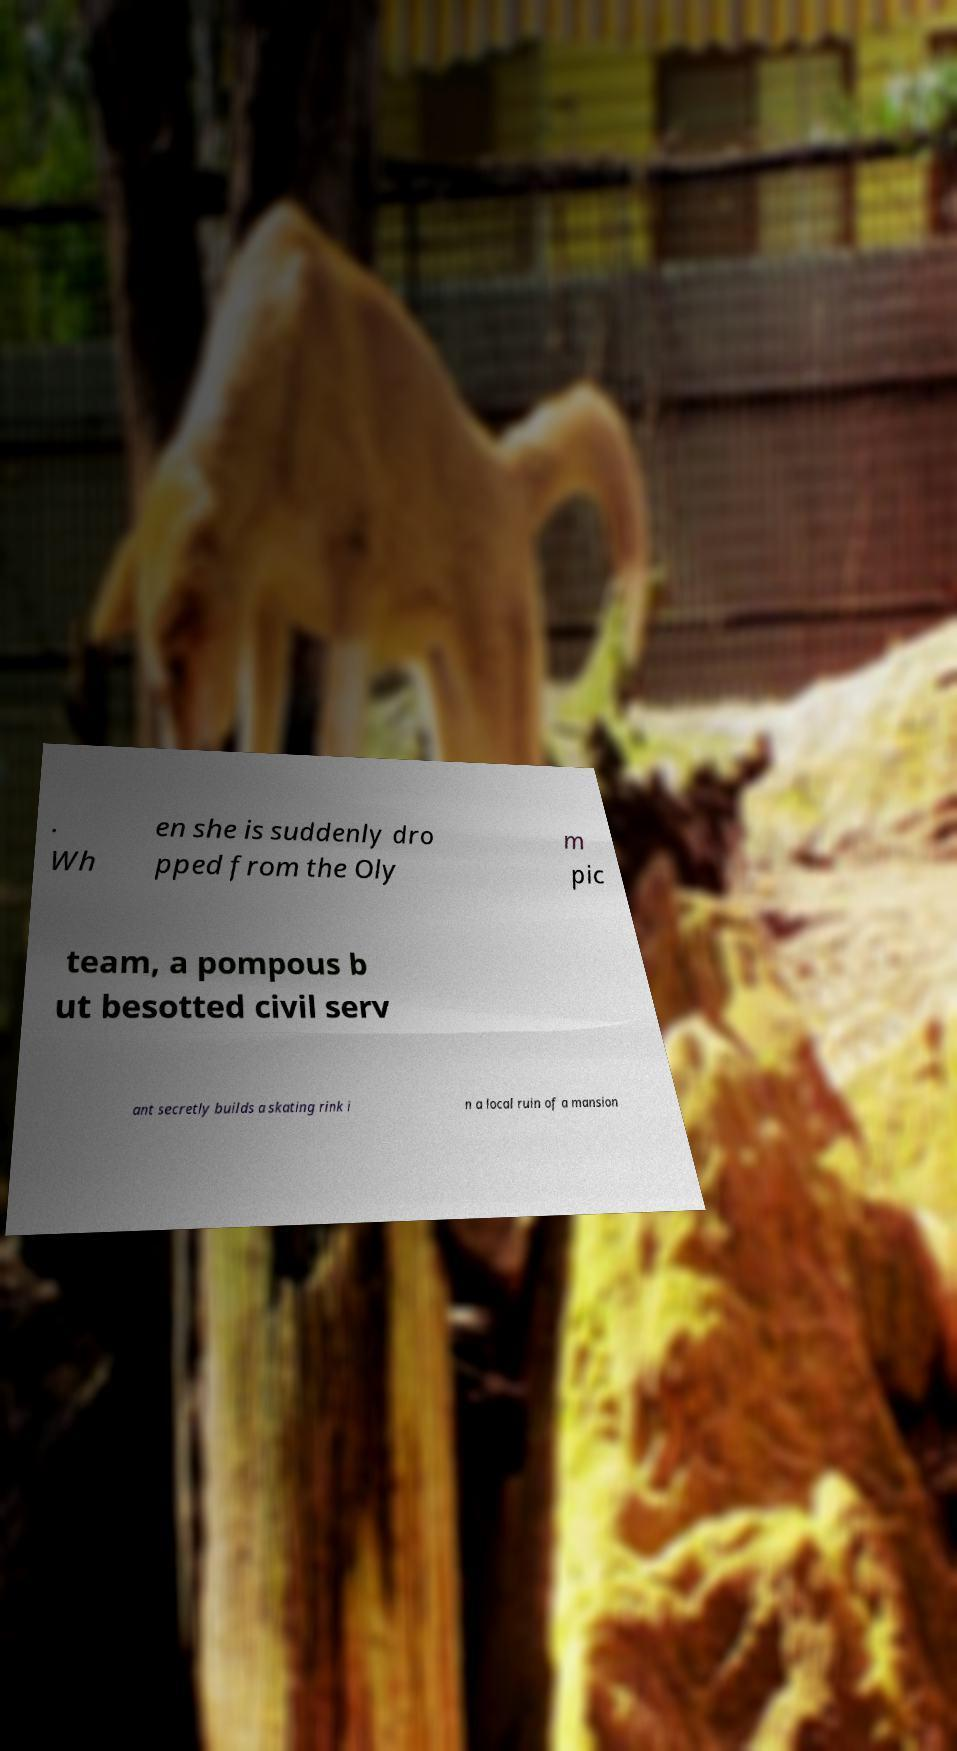Could you extract and type out the text from this image? . Wh en she is suddenly dro pped from the Oly m pic team, a pompous b ut besotted civil serv ant secretly builds a skating rink i n a local ruin of a mansion 